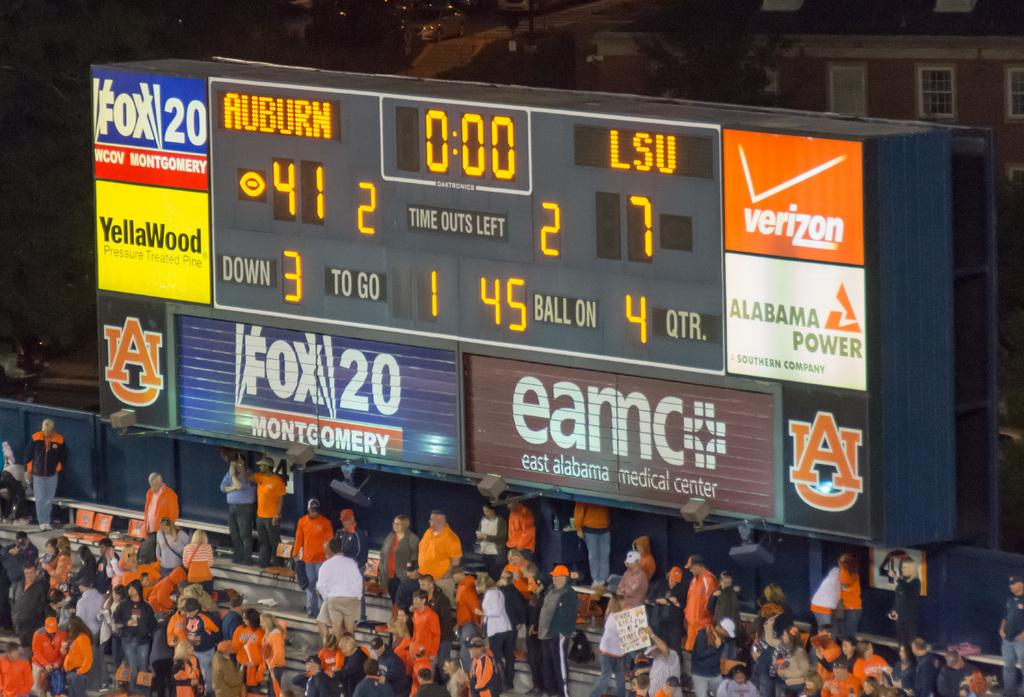Provide a one-sentence caption for the provided image. Auburn is leading LSU in the game 41 points to 7 points. 